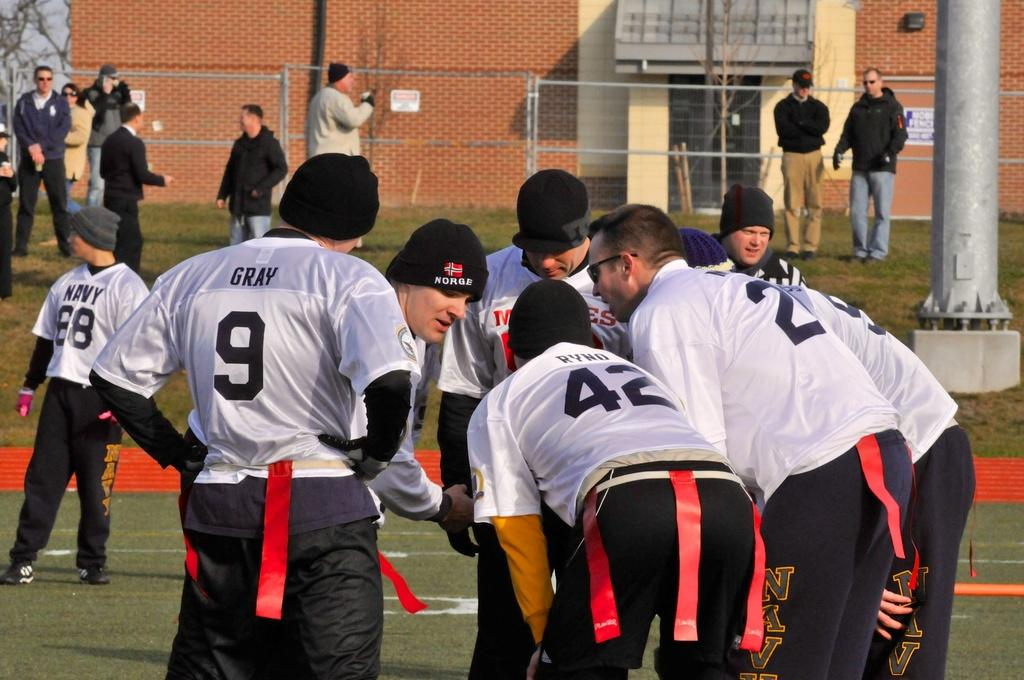<image>
Provide a brief description of the given image. A group of people one of them has a jersey that says gray number 9. 